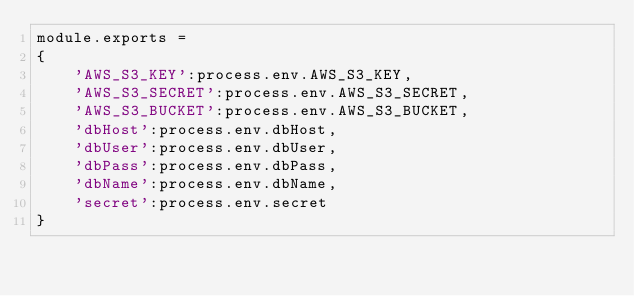Convert code to text. <code><loc_0><loc_0><loc_500><loc_500><_JavaScript_>module.exports =
{
	'AWS_S3_KEY':process.env.AWS_S3_KEY,
	'AWS_S3_SECRET':process.env.AWS_S3_SECRET,
	'AWS_S3_BUCKET':process.env.AWS_S3_BUCKET,
	'dbHost':process.env.dbHost,
	'dbUser':process.env.dbUser,
	'dbPass':process.env.dbPass,
	'dbName':process.env.dbName,
	'secret':process.env.secret
}</code> 